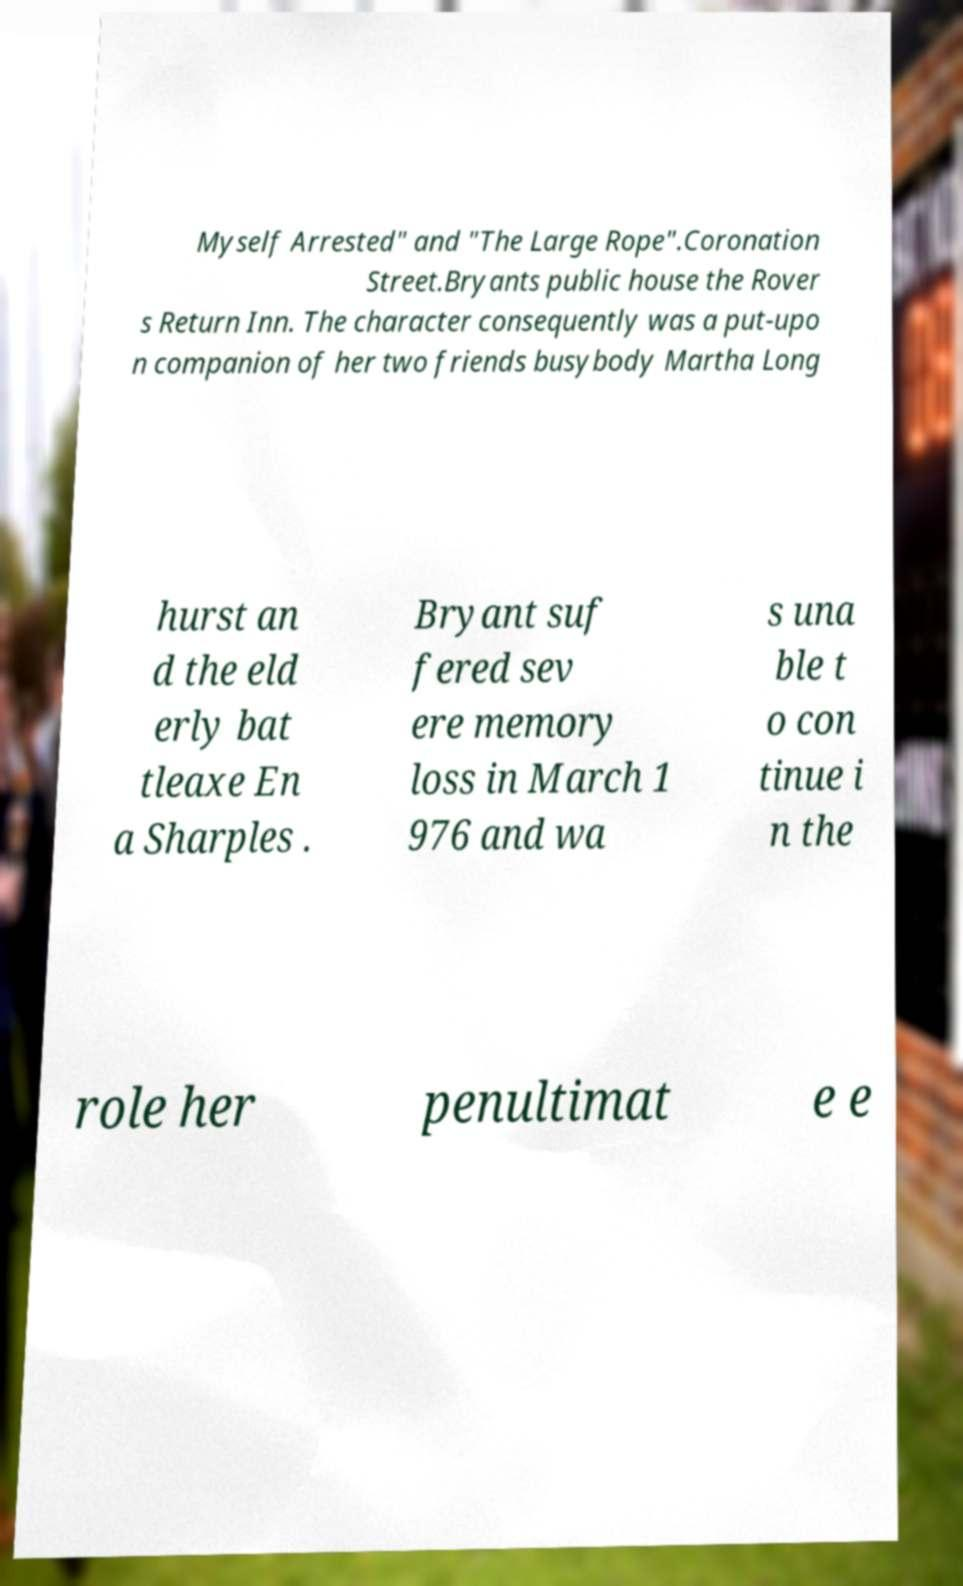Could you extract and type out the text from this image? Myself Arrested" and "The Large Rope".Coronation Street.Bryants public house the Rover s Return Inn. The character consequently was a put-upo n companion of her two friends busybody Martha Long hurst an d the eld erly bat tleaxe En a Sharples . Bryant suf fered sev ere memory loss in March 1 976 and wa s una ble t o con tinue i n the role her penultimat e e 